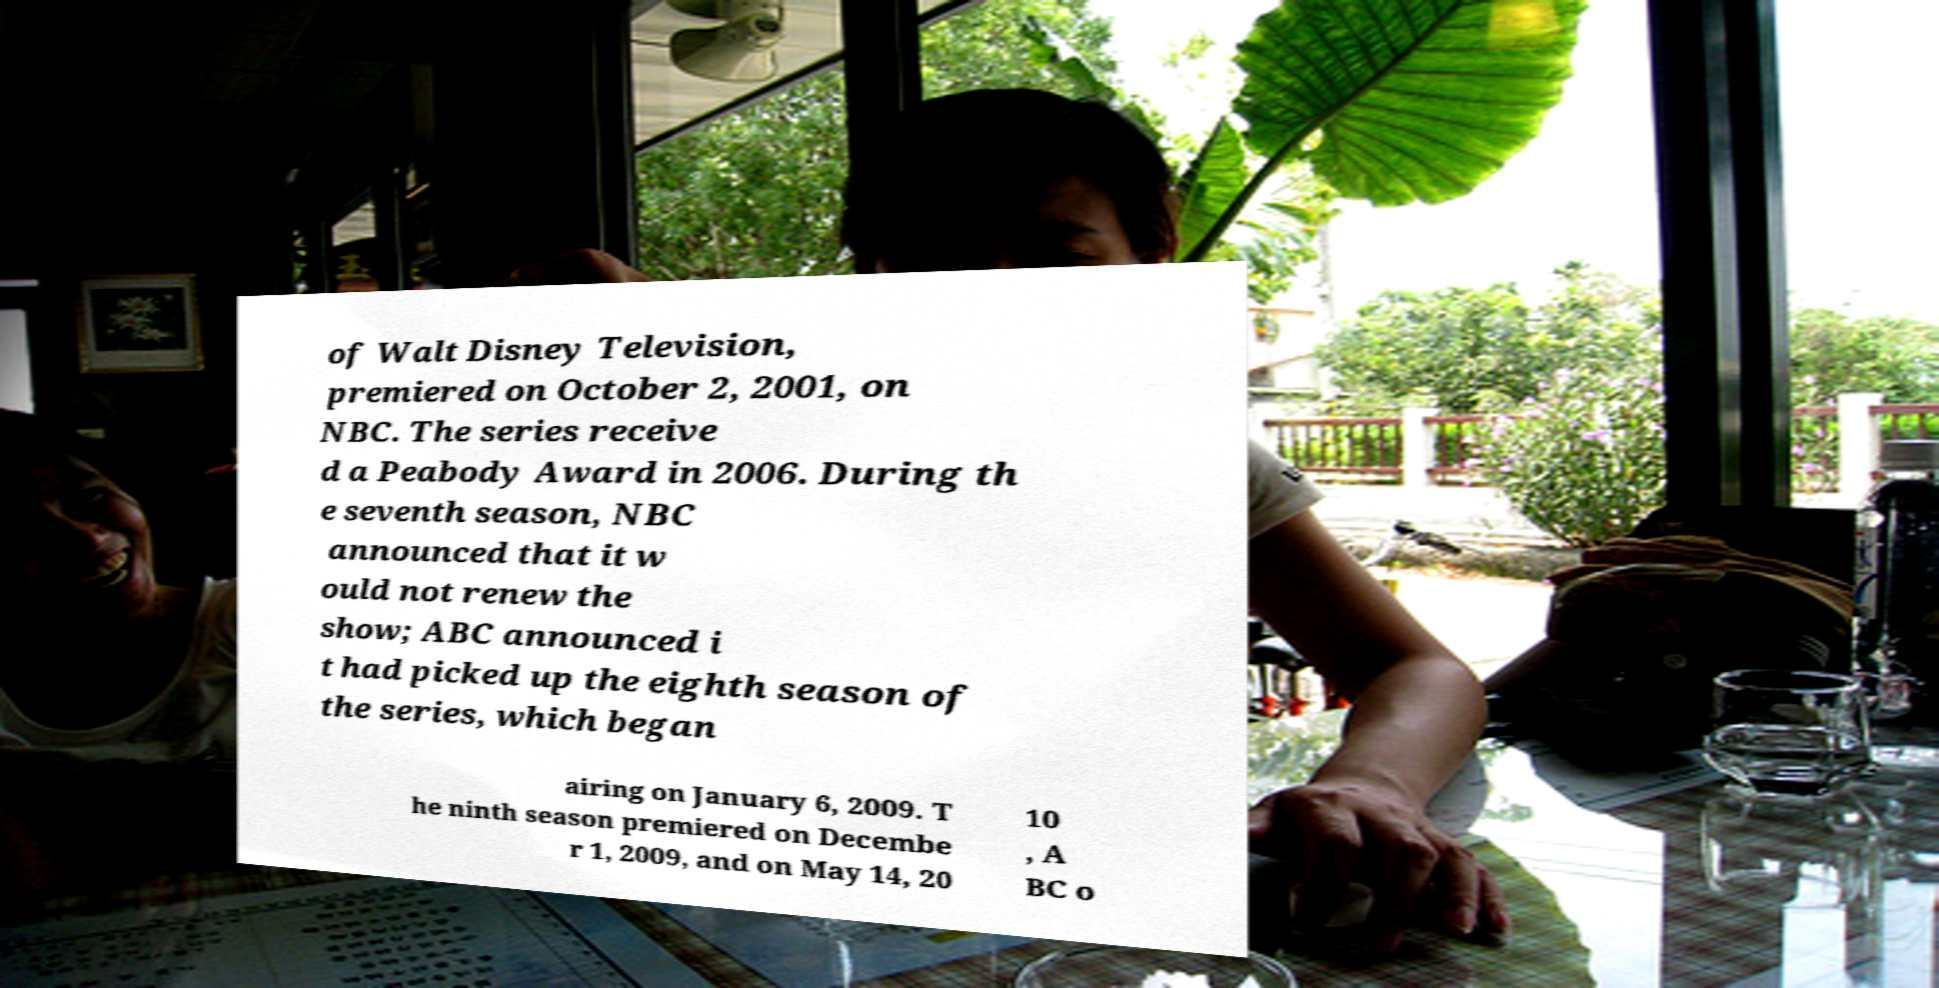For documentation purposes, I need the text within this image transcribed. Could you provide that? of Walt Disney Television, premiered on October 2, 2001, on NBC. The series receive d a Peabody Award in 2006. During th e seventh season, NBC announced that it w ould not renew the show; ABC announced i t had picked up the eighth season of the series, which began airing on January 6, 2009. T he ninth season premiered on Decembe r 1, 2009, and on May 14, 20 10 , A BC o 